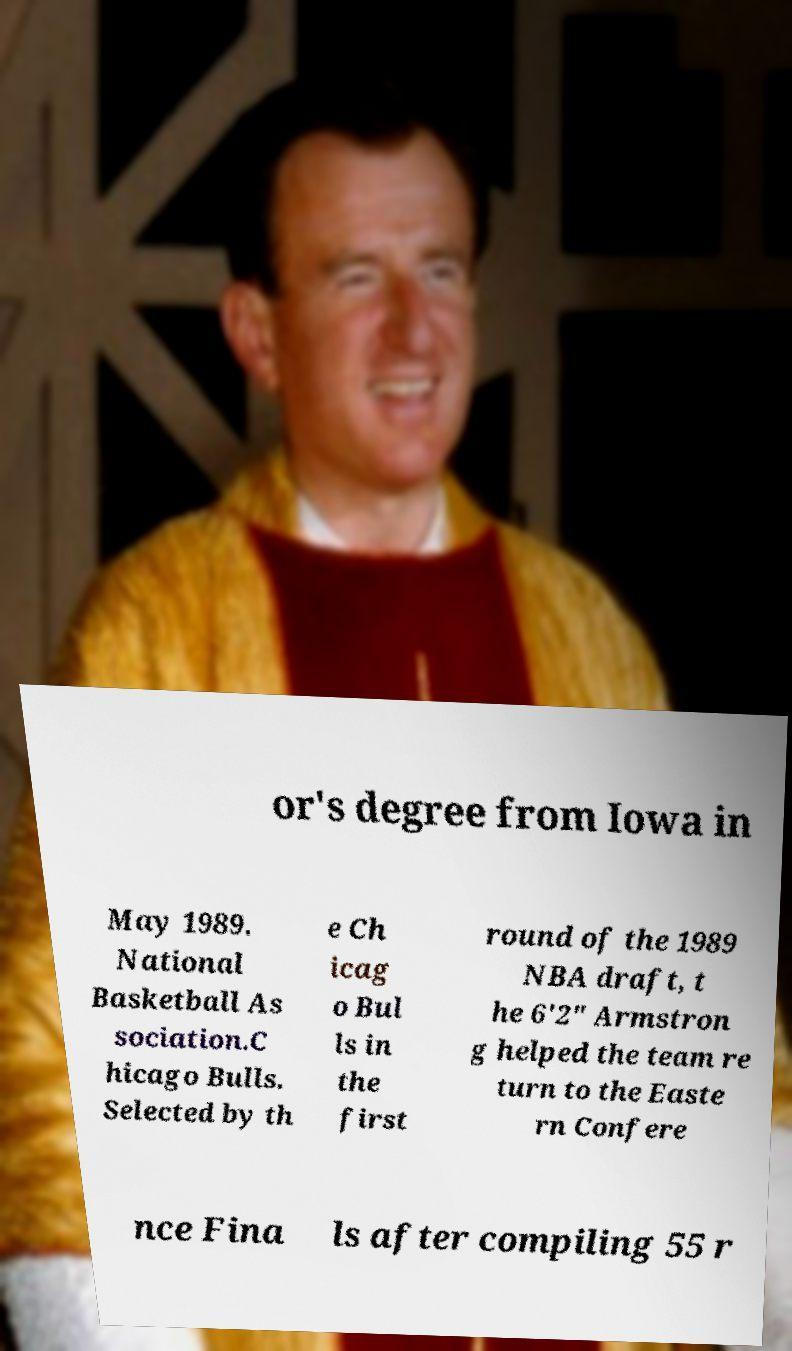Please read and relay the text visible in this image. What does it say? or's degree from Iowa in May 1989. National Basketball As sociation.C hicago Bulls. Selected by th e Ch icag o Bul ls in the first round of the 1989 NBA draft, t he 6'2" Armstron g helped the team re turn to the Easte rn Confere nce Fina ls after compiling 55 r 